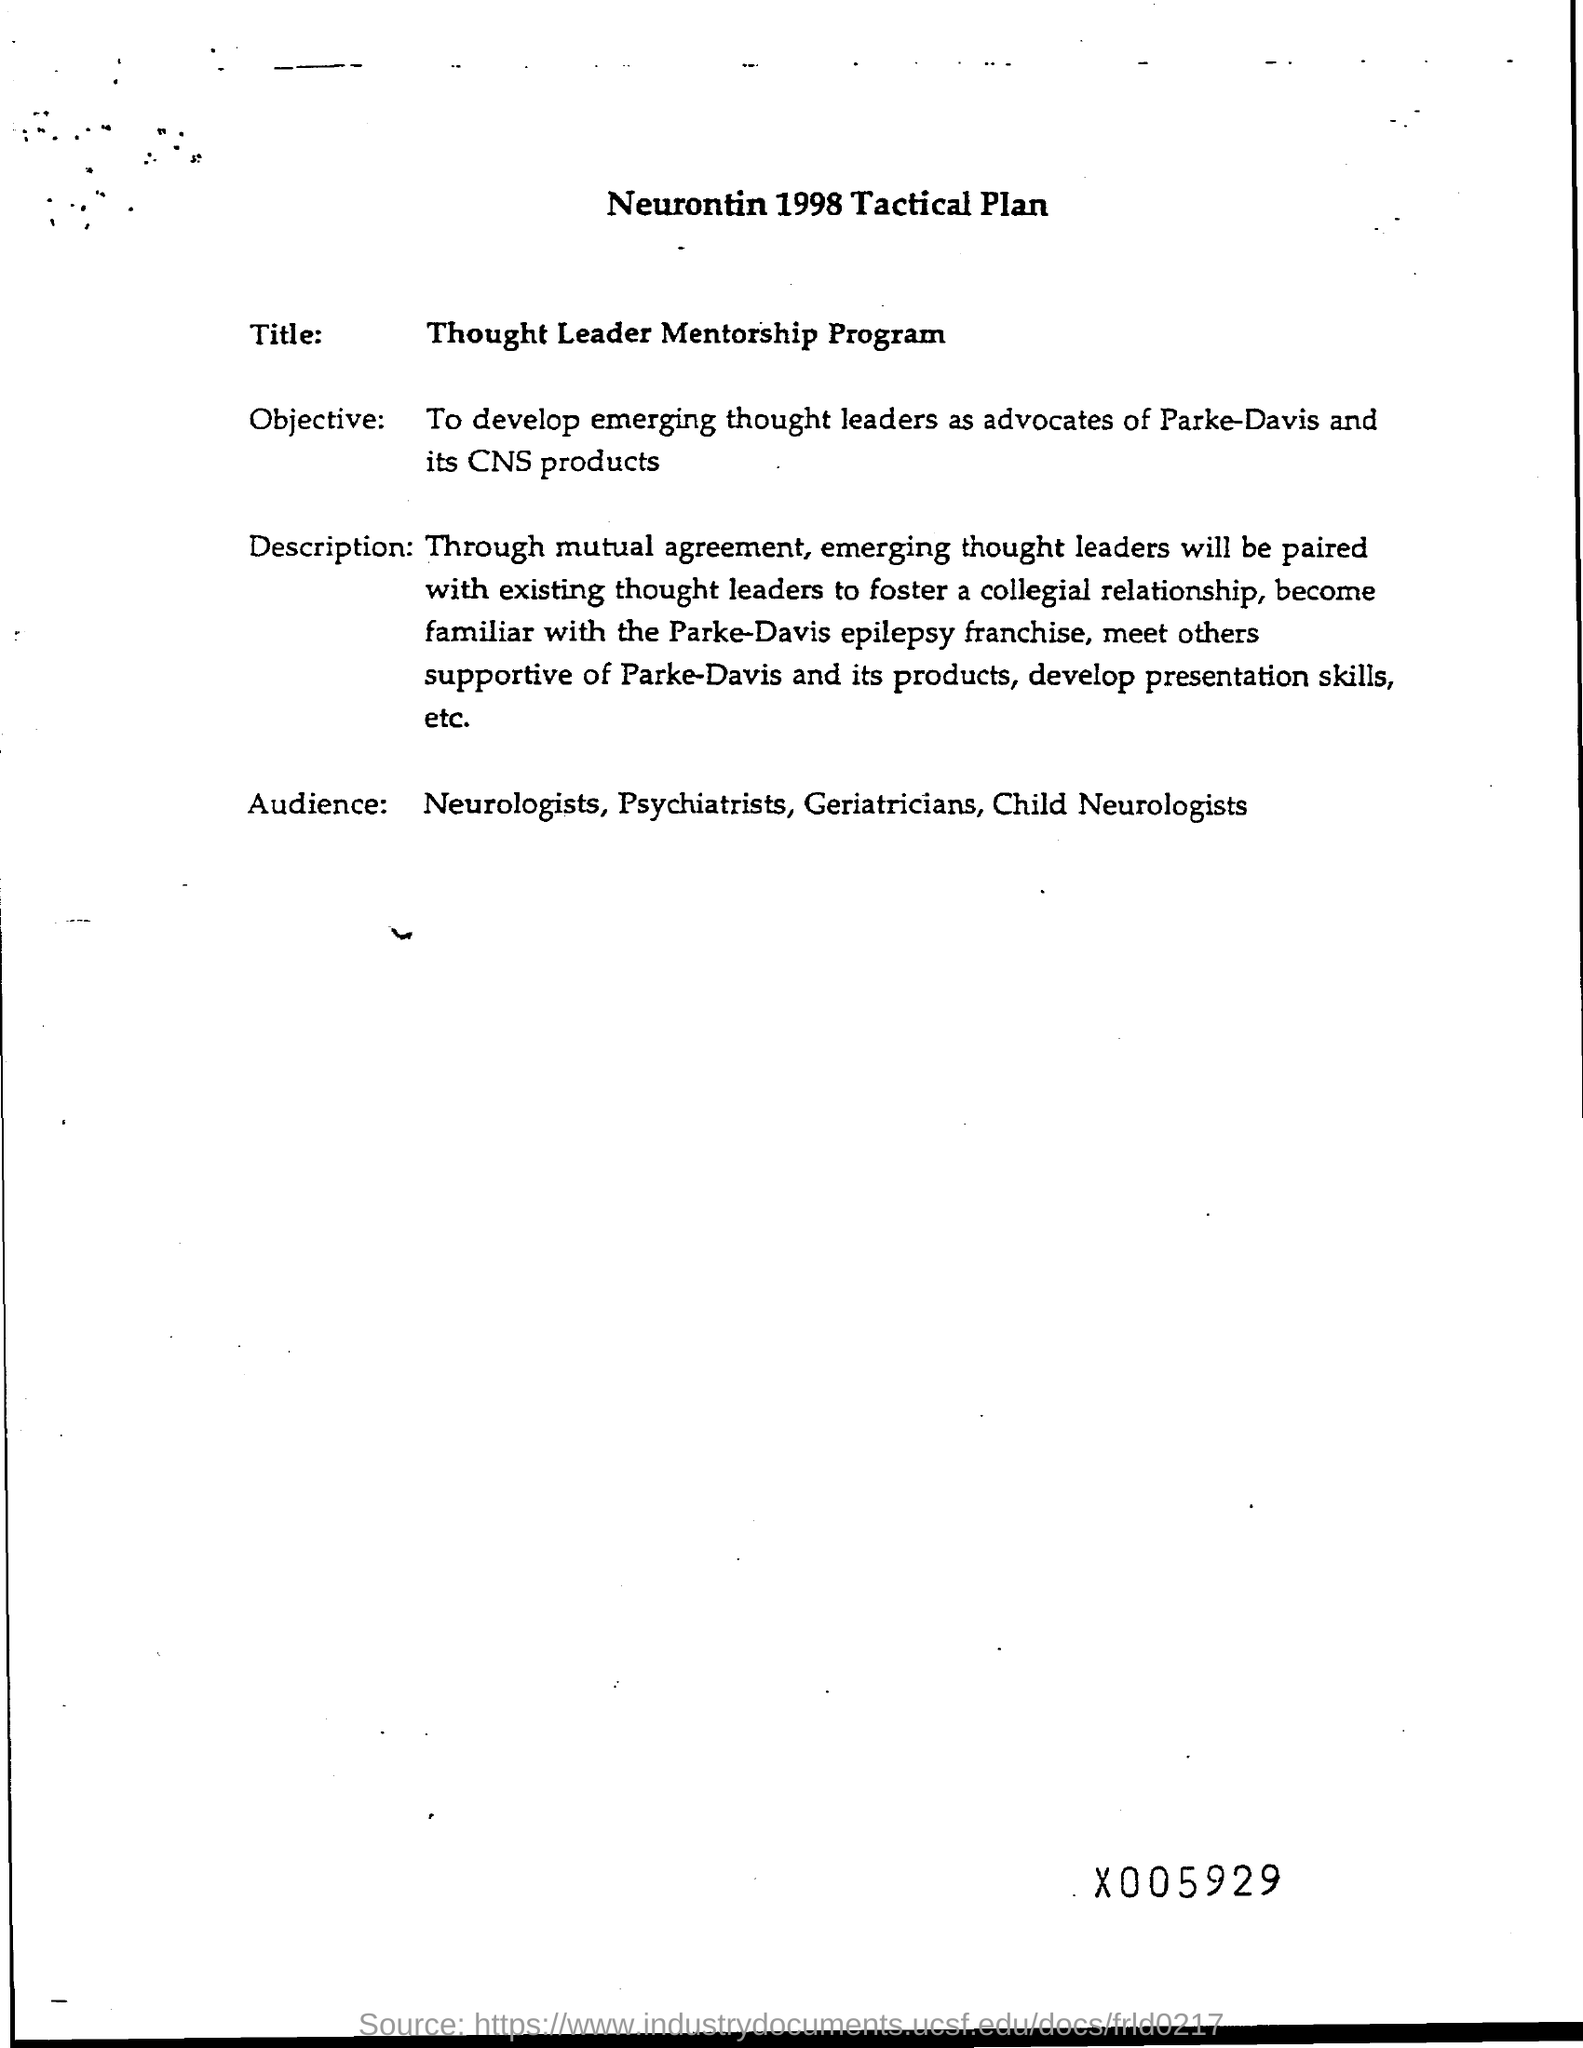What is the Title?
Keep it short and to the point. Thought Leader Mentorship Program. What is the Objective?
Give a very brief answer. To develop emerging thought leaders as advocates of Parke-Davis and its CNS products. Who are the Audience?
Make the answer very short. Neurologists, Psychiatrists, Geriatricians, Child Neurologists. 